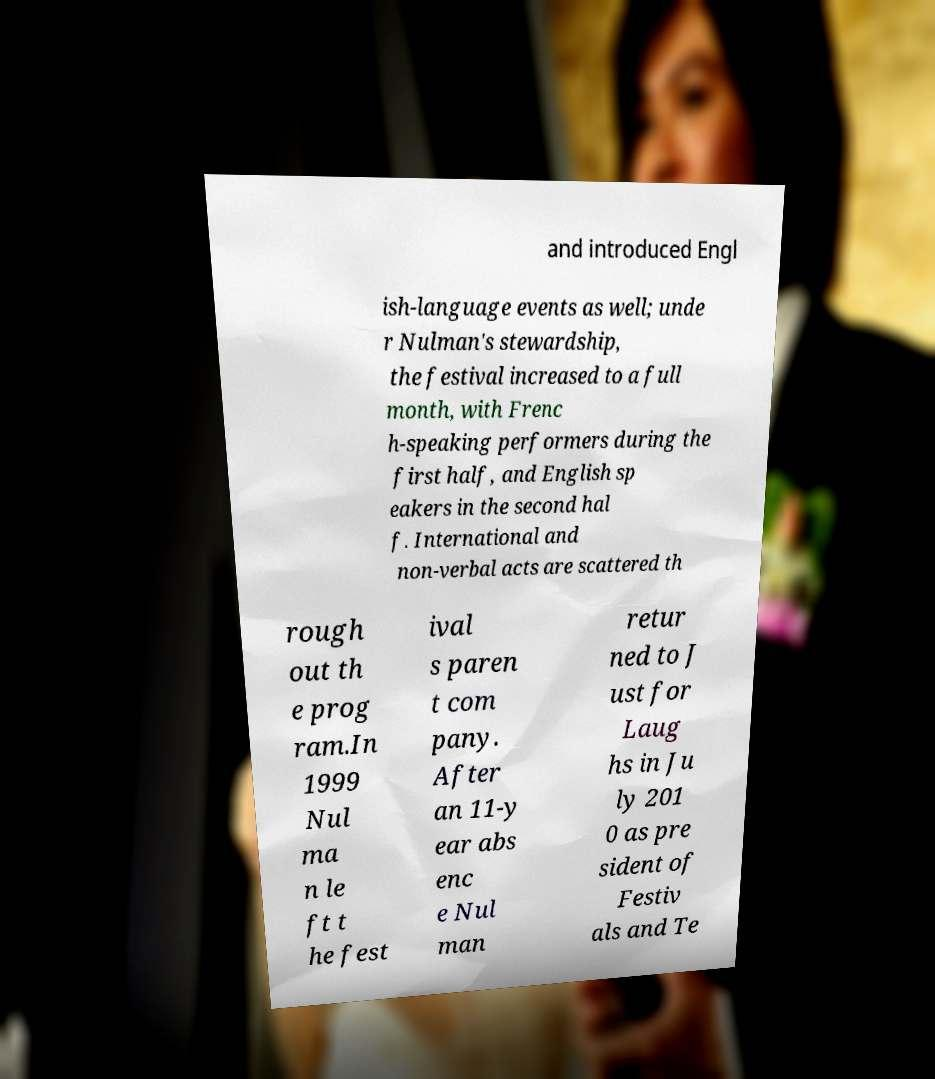Can you accurately transcribe the text from the provided image for me? and introduced Engl ish-language events as well; unde r Nulman's stewardship, the festival increased to a full month, with Frenc h-speaking performers during the first half, and English sp eakers in the second hal f. International and non-verbal acts are scattered th rough out th e prog ram.In 1999 Nul ma n le ft t he fest ival s paren t com pany. After an 11-y ear abs enc e Nul man retur ned to J ust for Laug hs in Ju ly 201 0 as pre sident of Festiv als and Te 